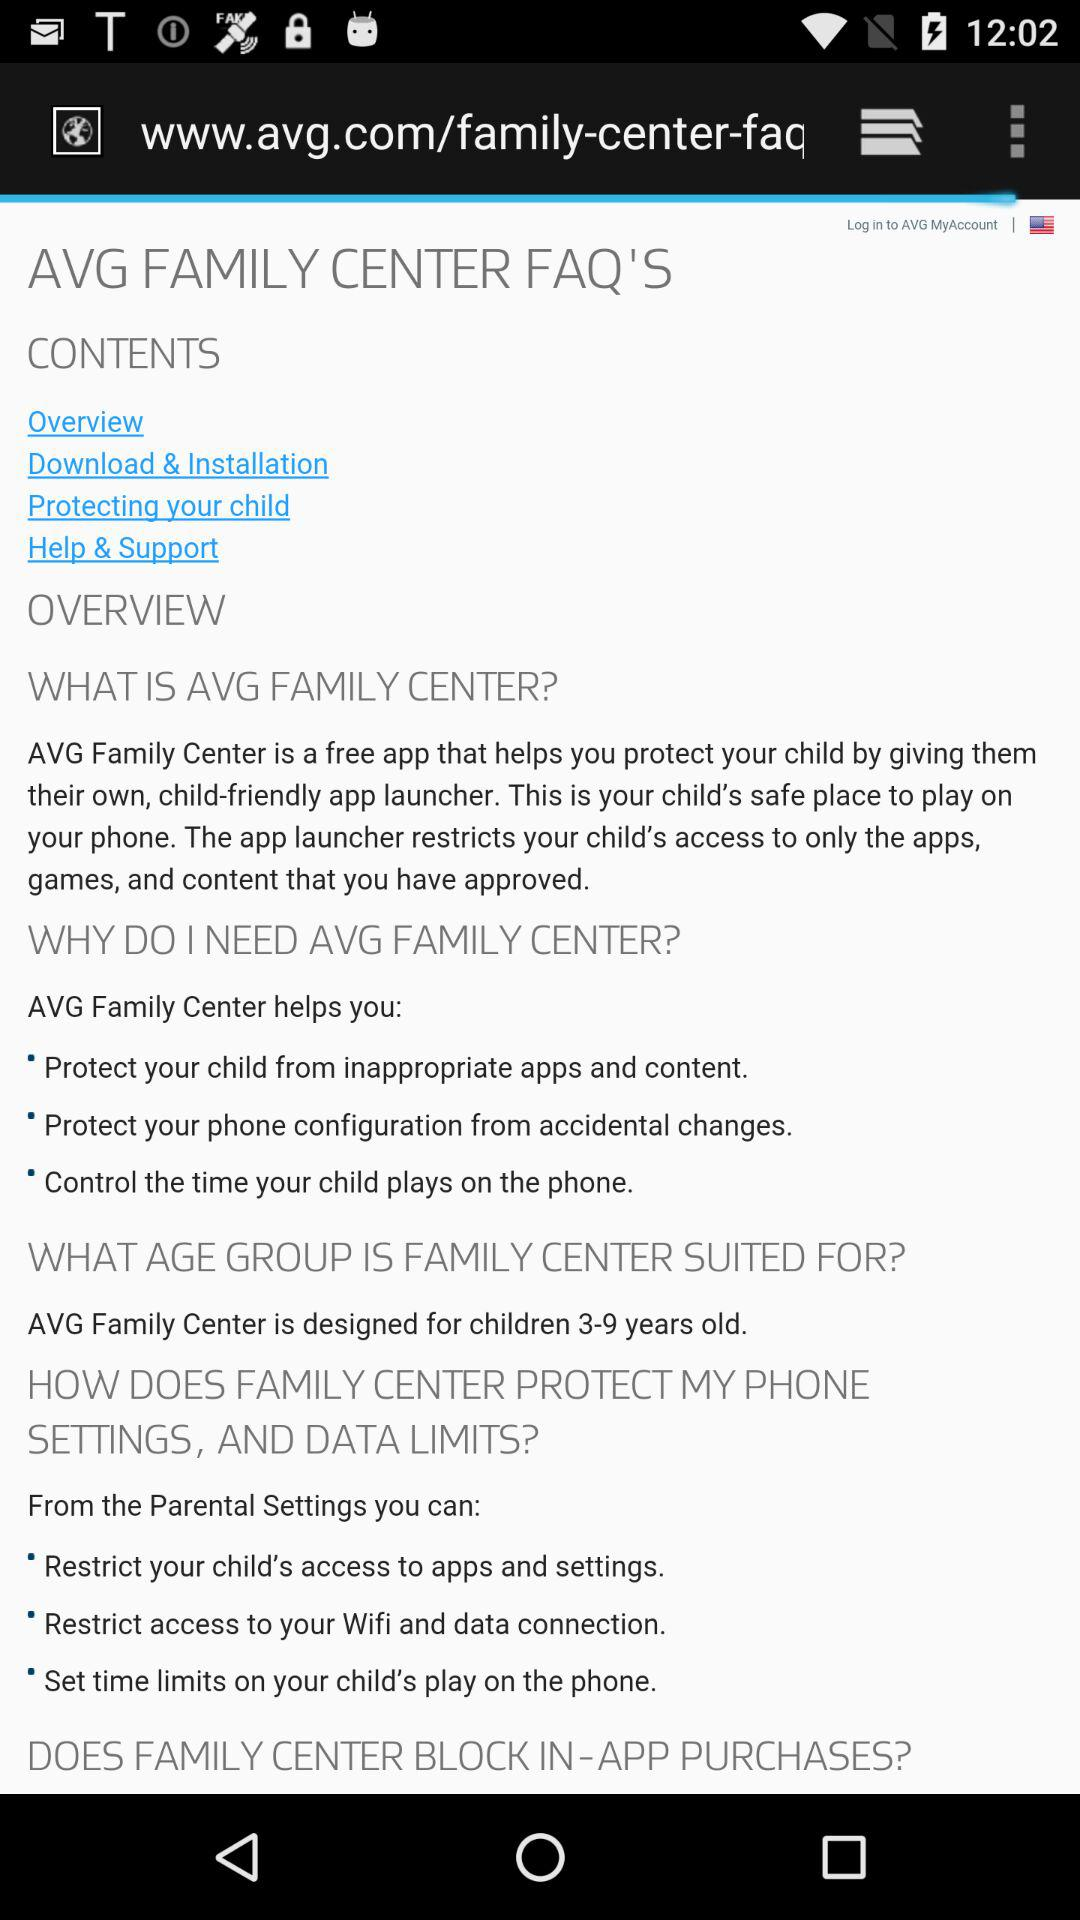How many FAQ sections are there?
Answer the question using a single word or phrase. 4 